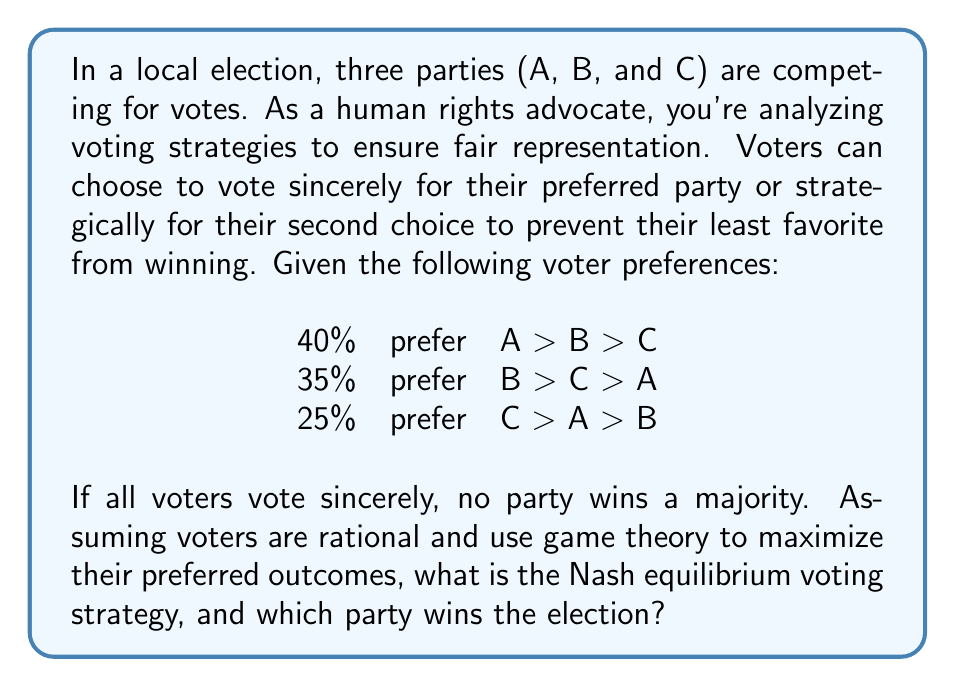Show me your answer to this math problem. To solve this problem, we need to analyze the potential strategies and outcomes using game theory principles:

1. Sincere voting scenario:
   Party A: 40%
   Party B: 35%
   Party C: 25%
   
   No party wins a majority (>50%).

2. Strategic voting analysis:
   - C voters (25%) can't influence the outcome alone, so they'll vote sincerely.
   - A voters (40%) prefer B over C, so they might consider voting for B strategically.
   - B voters (35%) prefer C over A, but voting for C would lead to A winning, so they'll vote sincerely.

3. Nash equilibrium calculation:
   Let $x$ be the fraction of A voters who vote strategically for B.
   
   Party A votes: $40(1-x)\%$
   Party B votes: $35 + 40x\%$
   Party C votes: $25\%$

   For B to win, we need:
   $35 + 40x > 40(1-x)$ and $35 + 40x > 25$

   Solving these inequalities:
   $75x > 5$ and $x > -0.25$
   
   $x > \frac{1}{15} \approx 0.0667$

4. Nash equilibrium strategy:
   If more than 6.67% of A voters vote strategically for B, B will win.
   All A voters have an incentive to vote strategically once this threshold is crossed.

5. Outcome:
   The Nash equilibrium is for all A voters to vote for B strategically.
   Final vote distribution:
   Party A: 0%
   Party B: 75%
   Party C: 25%
Answer: The Nash equilibrium voting strategy is for all voters who prefer Party A to vote strategically for Party B, while B and C voters vote sincerely. Party B wins the election with 75% of the votes. 